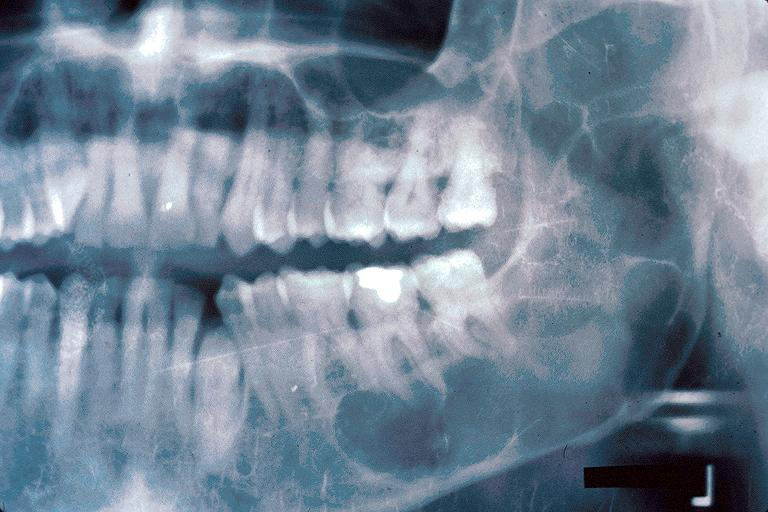what does this image show?
Answer the question using a single word or phrase. Odontogenic keratocyst 